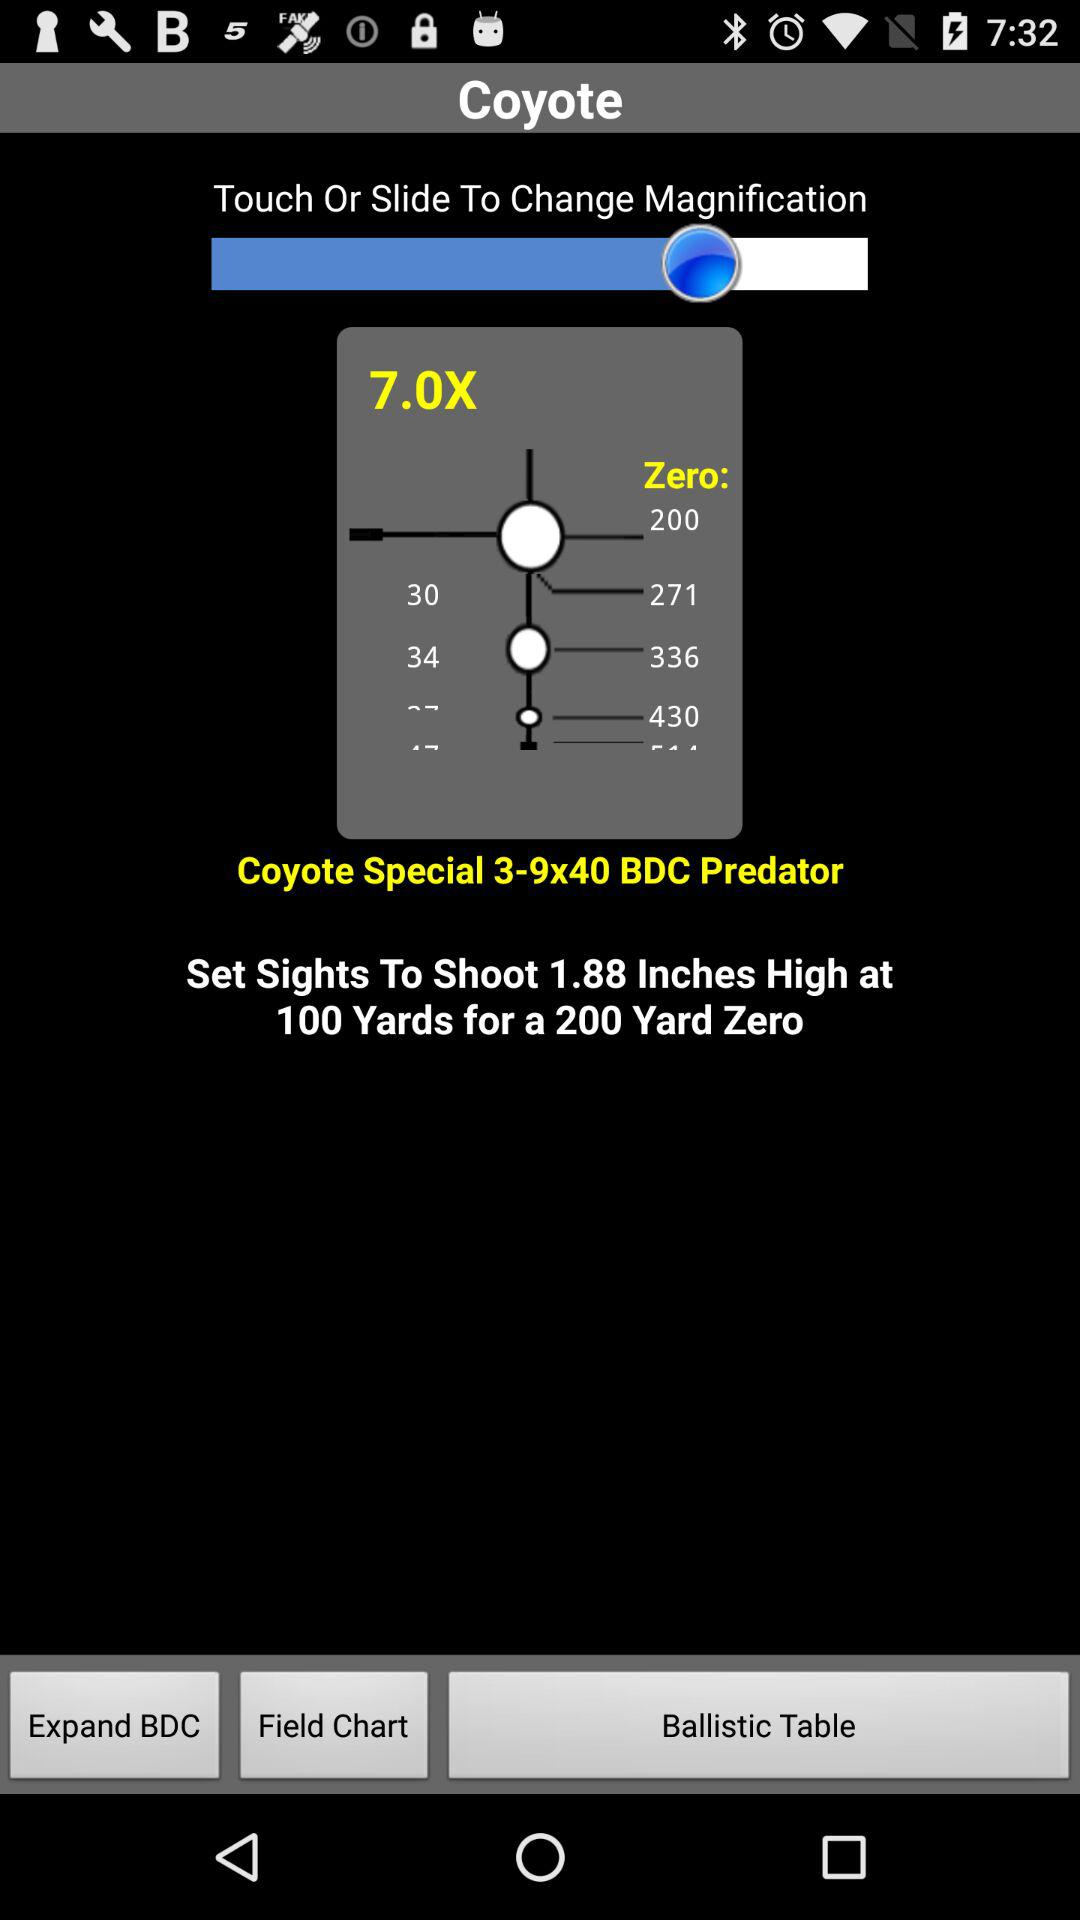How many more yards is the 300 yard zero than the 200 yard zero?
Answer the question using a single word or phrase. 100 